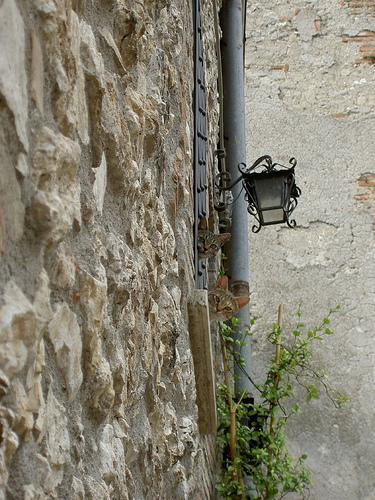Question: what color is the building?
Choices:
A. White.
B. Beige.
C. Grey.
D. Black.
Answer with the letter. Answer: B Question: where was the picture taken?
Choices:
A. Foot of a mountain.
B. By a bicycle rack.
C. Near a bar.
D. Outside a building.
Answer with the letter. Answer: D Question: what kind of light is illuminating the scene?
Choices:
A. Floodlight.
B. Black light.
C. Neon light.
D. Sunlight.
Answer with the letter. Answer: D Question: what color are the plant leaves?
Choices:
A. Green.
B. Brown.
C. Tan.
D. White.
Answer with the letter. Answer: A Question: how many lights are there?
Choices:
A. 1.
B. 3.
C. 4.
D. 8.
Answer with the letter. Answer: A Question: how many cat heads are there?
Choices:
A. 3.
B. 2.
C. 4.
D. 5.
Answer with the letter. Answer: B 